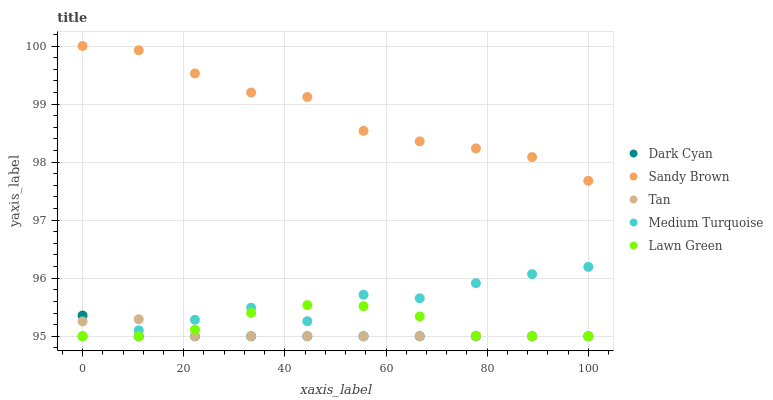Does Dark Cyan have the minimum area under the curve?
Answer yes or no. Yes. Does Sandy Brown have the maximum area under the curve?
Answer yes or no. Yes. Does Lawn Green have the minimum area under the curve?
Answer yes or no. No. Does Lawn Green have the maximum area under the curve?
Answer yes or no. No. Is Dark Cyan the smoothest?
Answer yes or no. Yes. Is Medium Turquoise the roughest?
Answer yes or no. Yes. Is Lawn Green the smoothest?
Answer yes or no. No. Is Lawn Green the roughest?
Answer yes or no. No. Does Dark Cyan have the lowest value?
Answer yes or no. Yes. Does Sandy Brown have the lowest value?
Answer yes or no. No. Does Sandy Brown have the highest value?
Answer yes or no. Yes. Does Lawn Green have the highest value?
Answer yes or no. No. Is Medium Turquoise less than Sandy Brown?
Answer yes or no. Yes. Is Sandy Brown greater than Tan?
Answer yes or no. Yes. Does Dark Cyan intersect Lawn Green?
Answer yes or no. Yes. Is Dark Cyan less than Lawn Green?
Answer yes or no. No. Is Dark Cyan greater than Lawn Green?
Answer yes or no. No. Does Medium Turquoise intersect Sandy Brown?
Answer yes or no. No. 